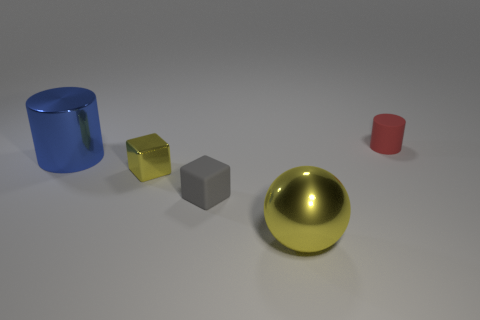Add 1 tiny yellow cubes. How many objects exist? 6 Subtract all balls. How many objects are left? 4 Subtract all blue things. Subtract all yellow spheres. How many objects are left? 3 Add 5 small metallic cubes. How many small metallic cubes are left? 6 Add 4 small gray things. How many small gray things exist? 5 Subtract 0 yellow cylinders. How many objects are left? 5 